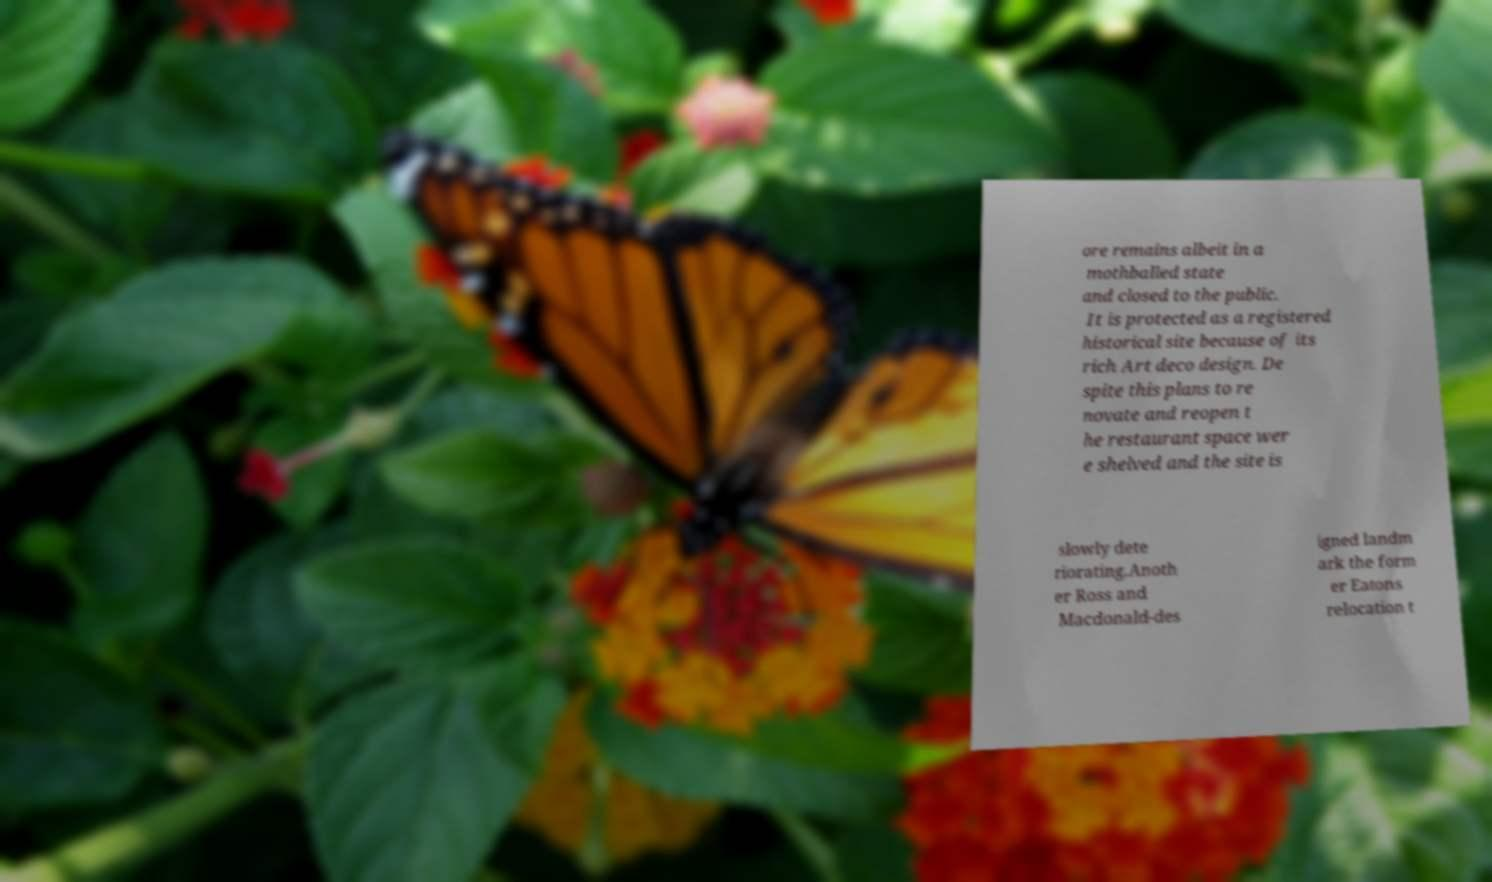Please identify and transcribe the text found in this image. ore remains albeit in a mothballed state and closed to the public. It is protected as a registered historical site because of its rich Art deco design. De spite this plans to re novate and reopen t he restaurant space wer e shelved and the site is slowly dete riorating.Anoth er Ross and Macdonald-des igned landm ark the form er Eatons relocation t 